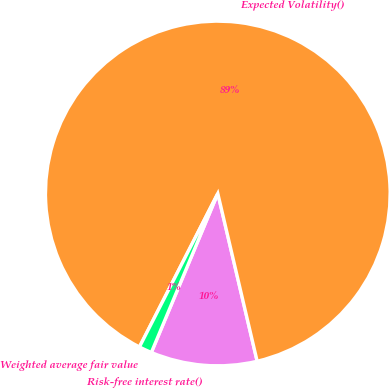Convert chart. <chart><loc_0><loc_0><loc_500><loc_500><pie_chart><fcel>Risk-free interest rate()<fcel>Expected Volatility()<fcel>Weighted average fair value<nl><fcel>9.97%<fcel>88.82%<fcel>1.21%<nl></chart> 